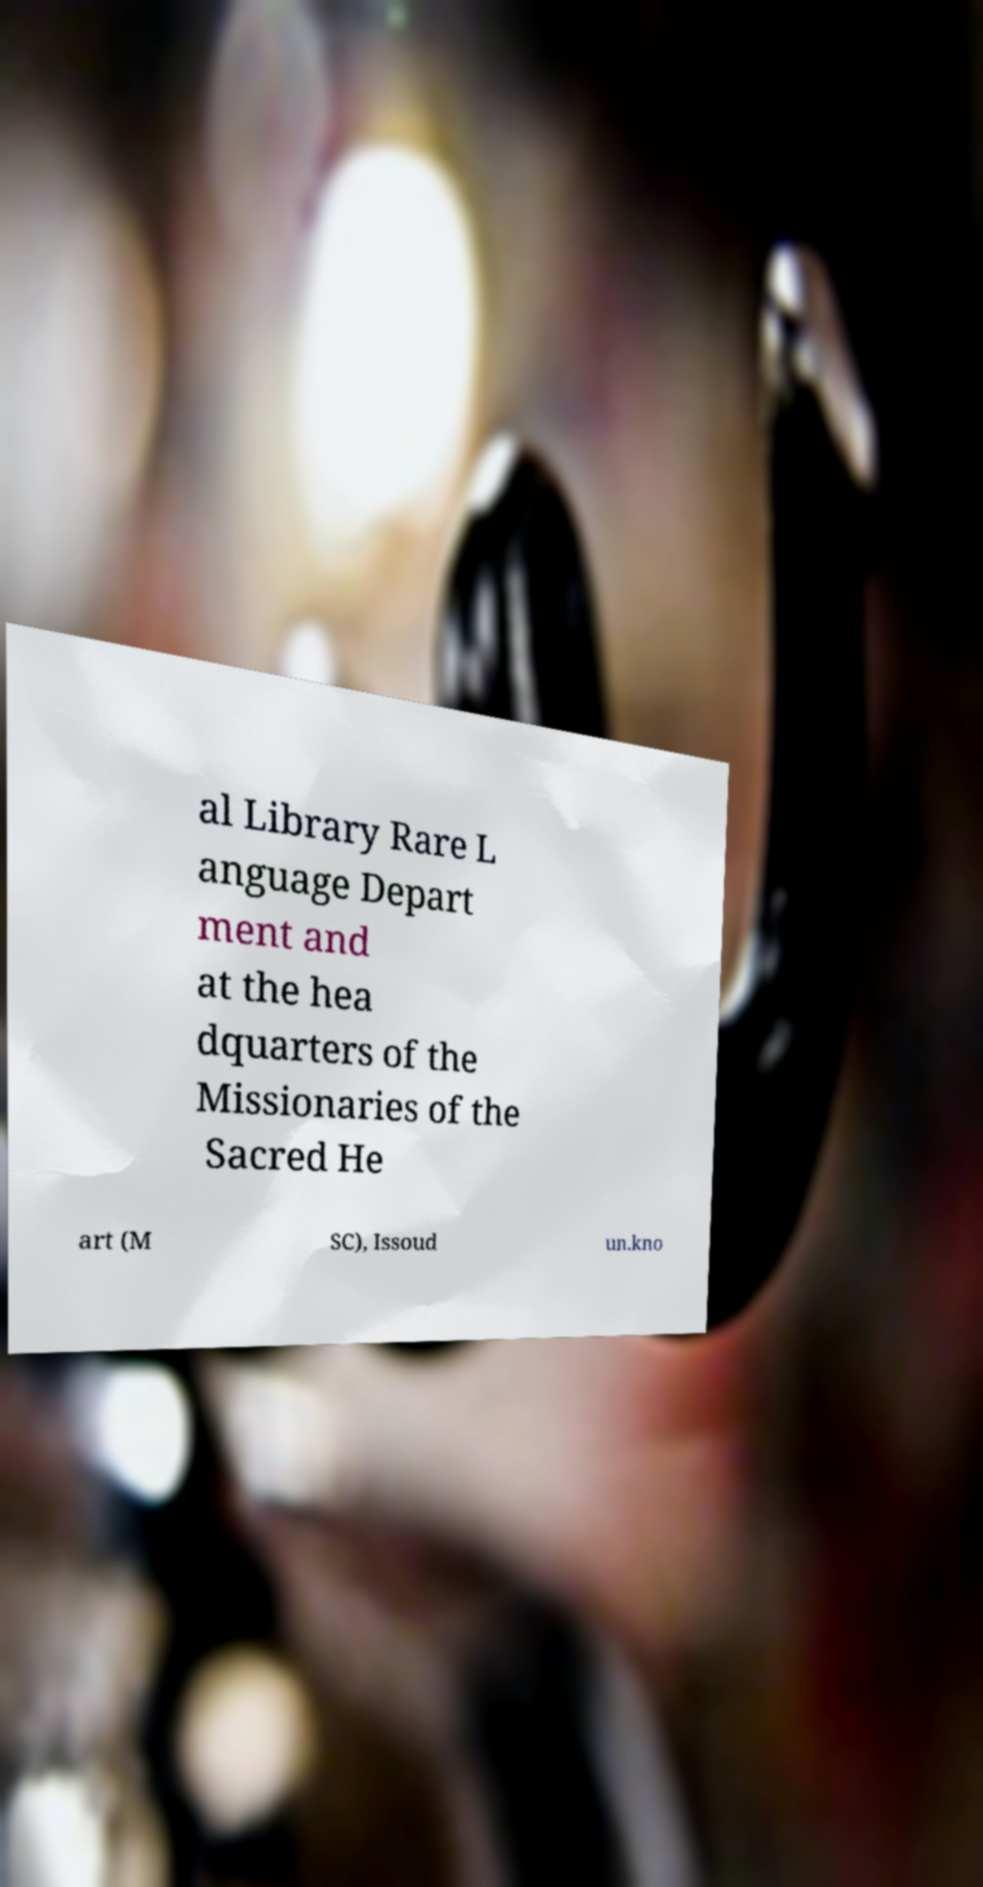Could you extract and type out the text from this image? al Library Rare L anguage Depart ment and at the hea dquarters of the Missionaries of the Sacred He art (M SC), Issoud un.kno 